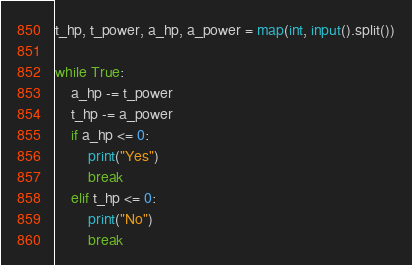<code> <loc_0><loc_0><loc_500><loc_500><_Python_>t_hp, t_power, a_hp, a_power = map(int, input().split())

while True:
    a_hp -= t_power
    t_hp -= a_power
    if a_hp <= 0:
        print("Yes")
        break
    elif t_hp <= 0:
        print("No")
        break</code> 